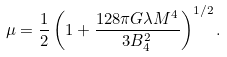<formula> <loc_0><loc_0><loc_500><loc_500>\mu = \frac { 1 } { 2 } \left ( 1 + \frac { 1 2 8 \pi G \lambda M ^ { 4 } } { 3 B _ { 4 } ^ { 2 } } \right ) ^ { 1 / 2 } .</formula> 